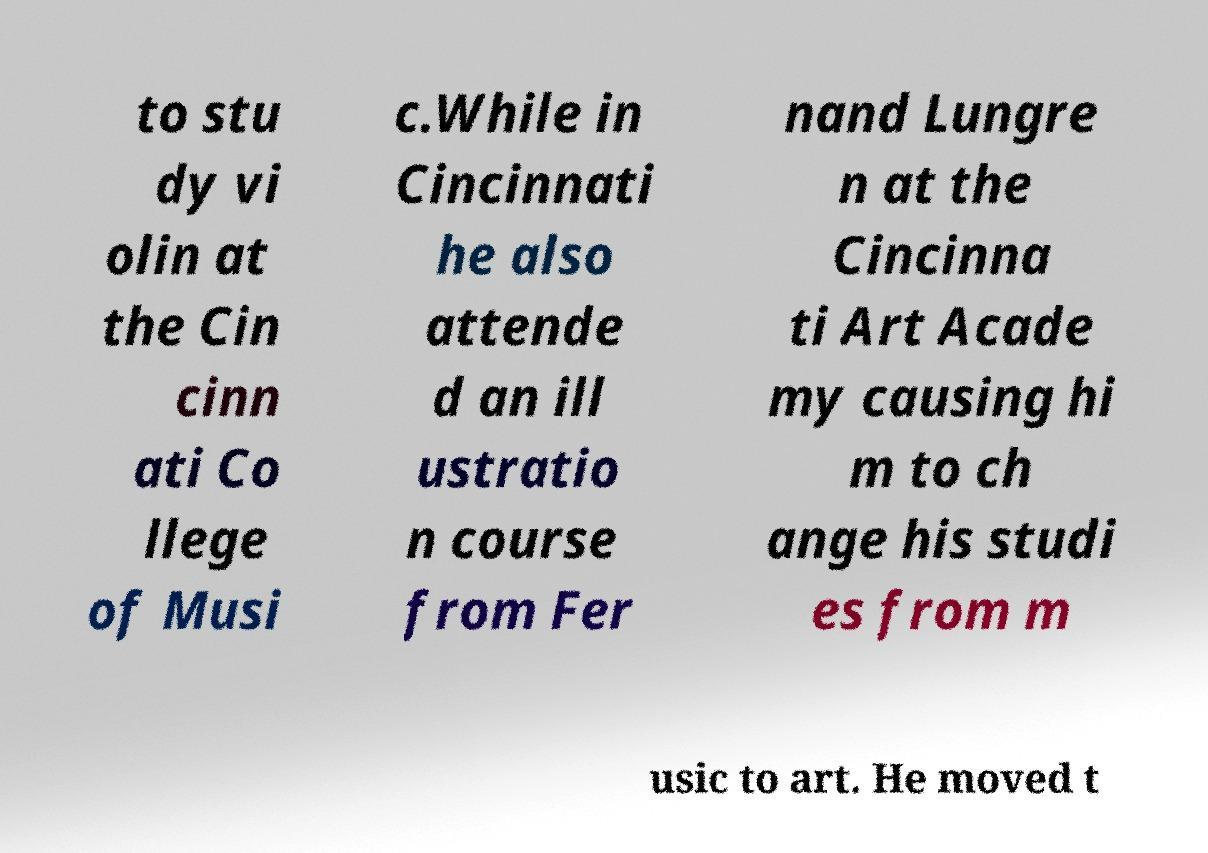I need the written content from this picture converted into text. Can you do that? to stu dy vi olin at the Cin cinn ati Co llege of Musi c.While in Cincinnati he also attende d an ill ustratio n course from Fer nand Lungre n at the Cincinna ti Art Acade my causing hi m to ch ange his studi es from m usic to art. He moved t 